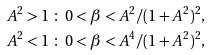Convert formula to latex. <formula><loc_0><loc_0><loc_500><loc_500>& A ^ { 2 } > 1 \ \colon \ 0 < \beta < A ^ { 2 } / ( 1 + A ^ { 2 } ) ^ { 2 } , \\ & A ^ { 2 } < 1 \ \colon \ 0 < \beta < A ^ { 4 } / ( 1 + A ^ { 2 } ) ^ { 2 } ,</formula> 